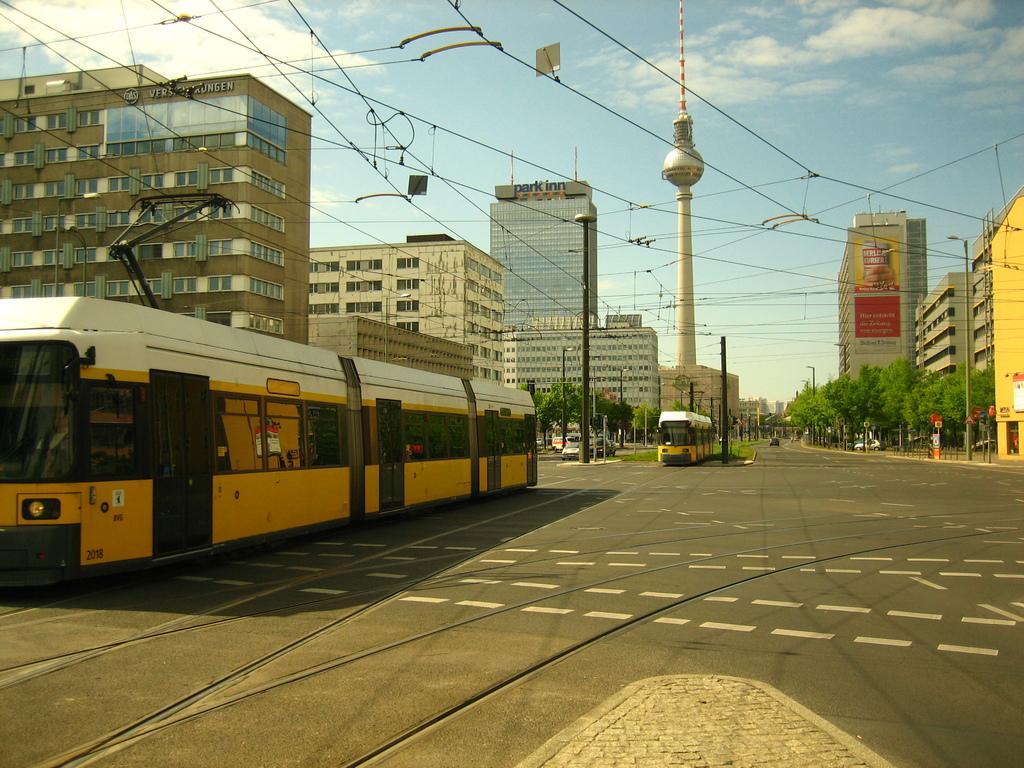Can you describe this image briefly? In this image, we can see some buildings and trams. There are trams on the right side of the image. There are poles beside the road. There is a tower in the middle of the image. There are clouds in the sky. 